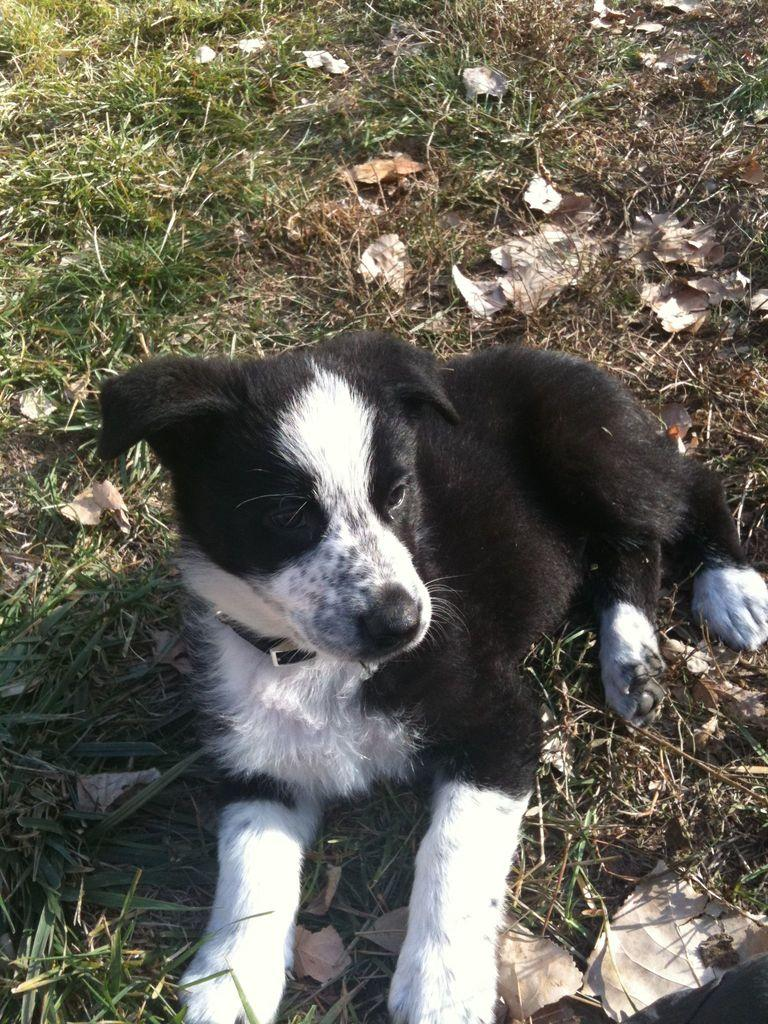What type of animal is in the image? There is a dog in the image. Where is the dog located? The dog is on the ground. What can be seen in the background of the image? There are dried leaves on the grass in the background of the image. What type of drain can be seen in the image? There is no drain present in the image; it features a dog on the ground with dried leaves on the grass in the background. 